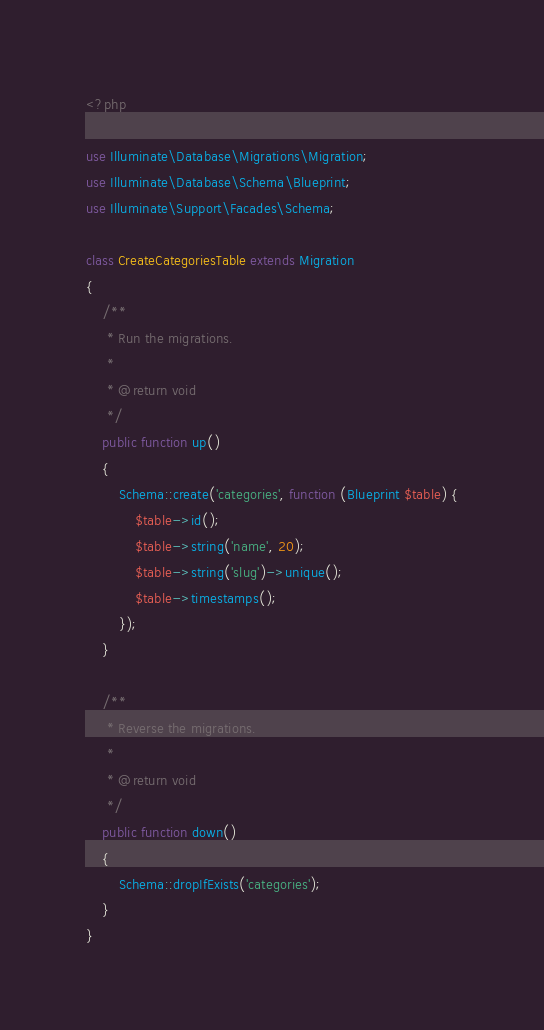Convert code to text. <code><loc_0><loc_0><loc_500><loc_500><_PHP_><?php

use Illuminate\Database\Migrations\Migration;
use Illuminate\Database\Schema\Blueprint;
use Illuminate\Support\Facades\Schema;

class CreateCategoriesTable extends Migration
{
    /**
     * Run the migrations.
     *
     * @return void
     */
    public function up()
    {
        Schema::create('categories', function (Blueprint $table) {
            $table->id();
            $table->string('name', 20);
            $table->string('slug')->unique();
            $table->timestamps();
        });
    }

    /**
     * Reverse the migrations.
     *
     * @return void
     */
    public function down()
    {
        Schema::dropIfExists('categories');
    }
}
</code> 